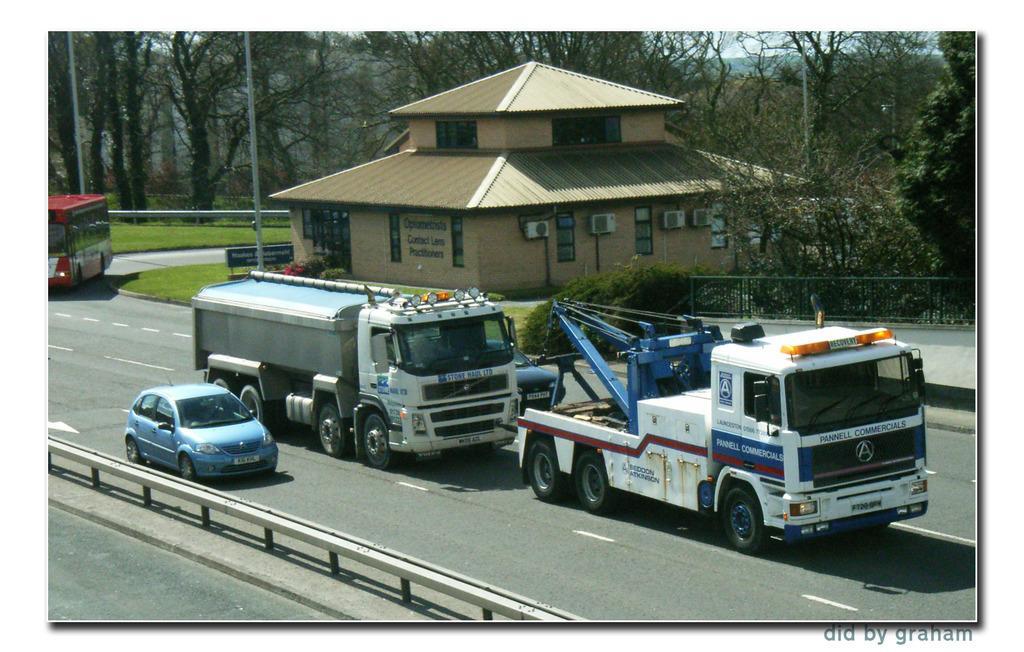Can you describe this image briefly? This is a photo. In the center of the image we can see a house, boards, text, air conditioners, windows. In the background of the image we can see the trees, poles, grilles, grass, vehicles, road. At the bottom of the image we can see the railing. At the top of the image we can see the sky. In the bottom right corner we can see the text. 